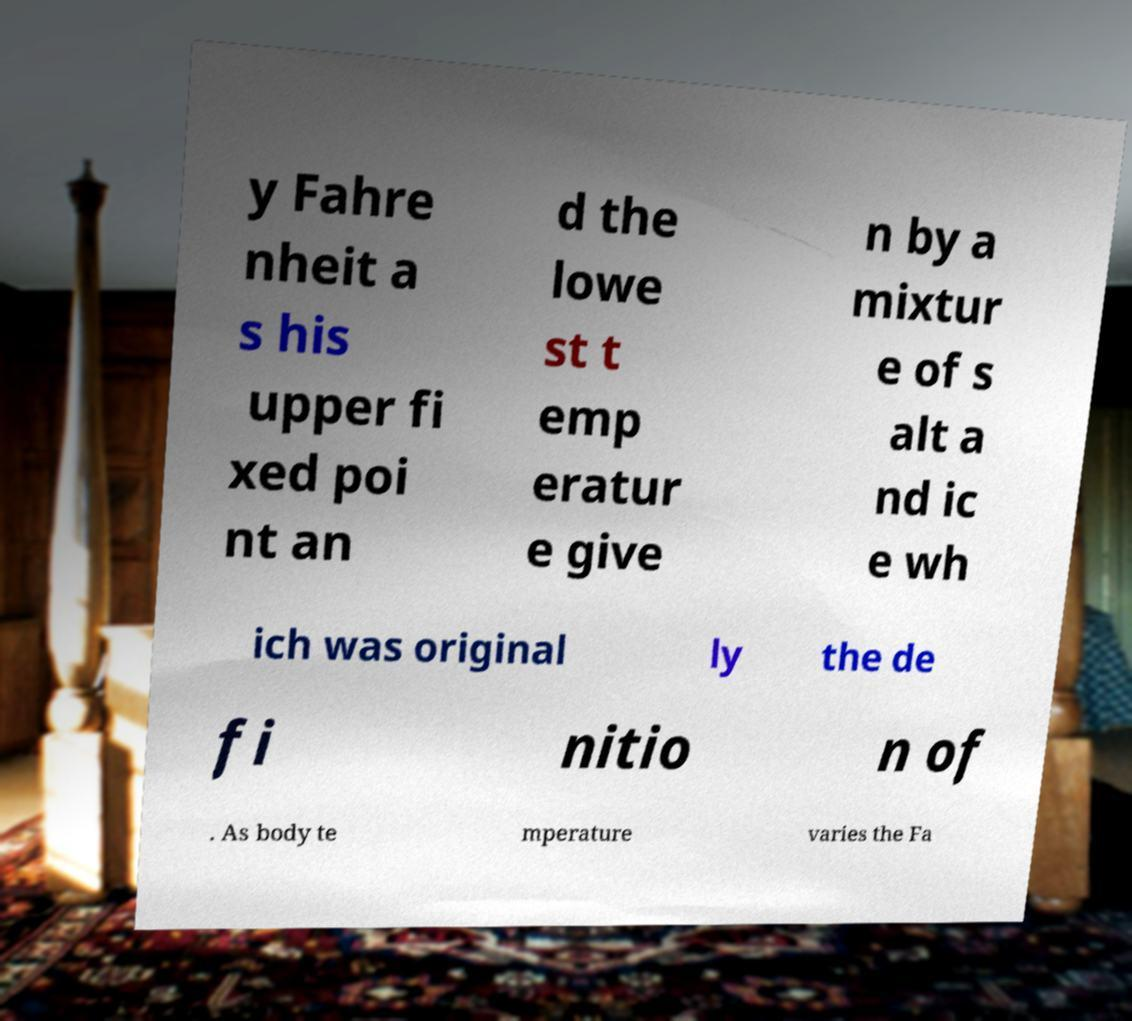I need the written content from this picture converted into text. Can you do that? y Fahre nheit a s his upper fi xed poi nt an d the lowe st t emp eratur e give n by a mixtur e of s alt a nd ic e wh ich was original ly the de fi nitio n of . As body te mperature varies the Fa 